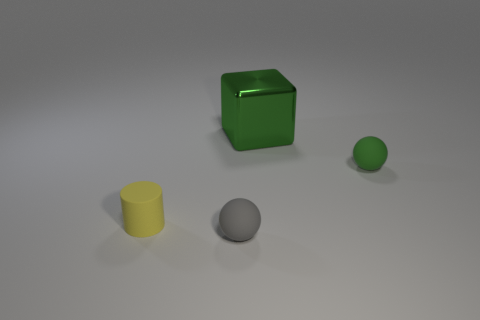What shape is the gray object that is the same size as the green rubber thing?
Offer a very short reply. Sphere. There is a green thing that is in front of the shiny thing to the left of the green rubber ball; are there any blocks on the right side of it?
Provide a short and direct response. No. Do the large metallic object and the tiny rubber ball that is left of the block have the same color?
Offer a very short reply. No. What number of other tiny matte cylinders are the same color as the tiny matte cylinder?
Offer a terse response. 0. There is a ball in front of the matte ball on the right side of the green shiny cube; what is its size?
Offer a terse response. Small. How many objects are either rubber spheres that are on the right side of the large green thing or green objects?
Provide a short and direct response. 2. Is there a green shiny object of the same size as the green matte thing?
Make the answer very short. No. There is a object on the left side of the tiny gray rubber sphere; are there any tiny green matte objects in front of it?
Ensure brevity in your answer.  No. How many cubes are either brown things or yellow objects?
Your answer should be very brief. 0. Is there a small yellow matte thing that has the same shape as the gray rubber object?
Your answer should be very brief. No. 